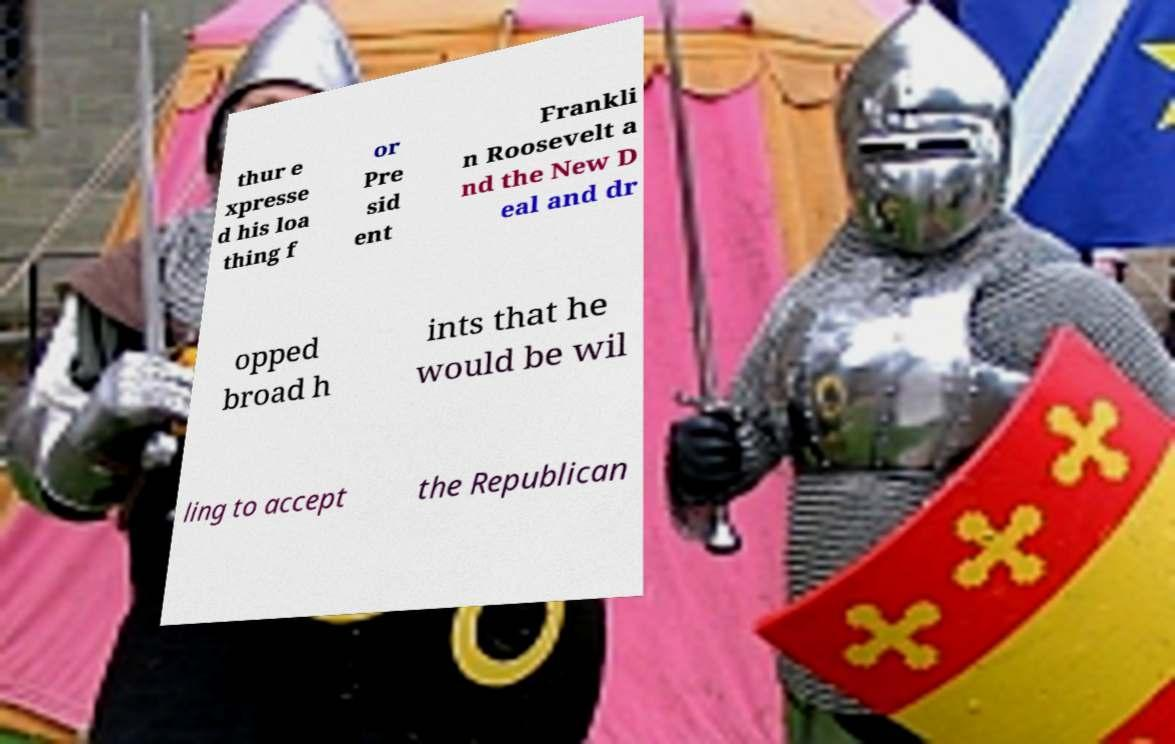What might be the context or event where this photo was taken? Considering the attire of the individuals and the medieval-style tents in the background, this photo was most likely taken at a medieval reenactment event, a Renaissance fair, or a themed theatrical performance. These events often feature historical recreations, demonstrations of combat, and traditional crafts to educate and entertain visitors about medieval life and culture. 